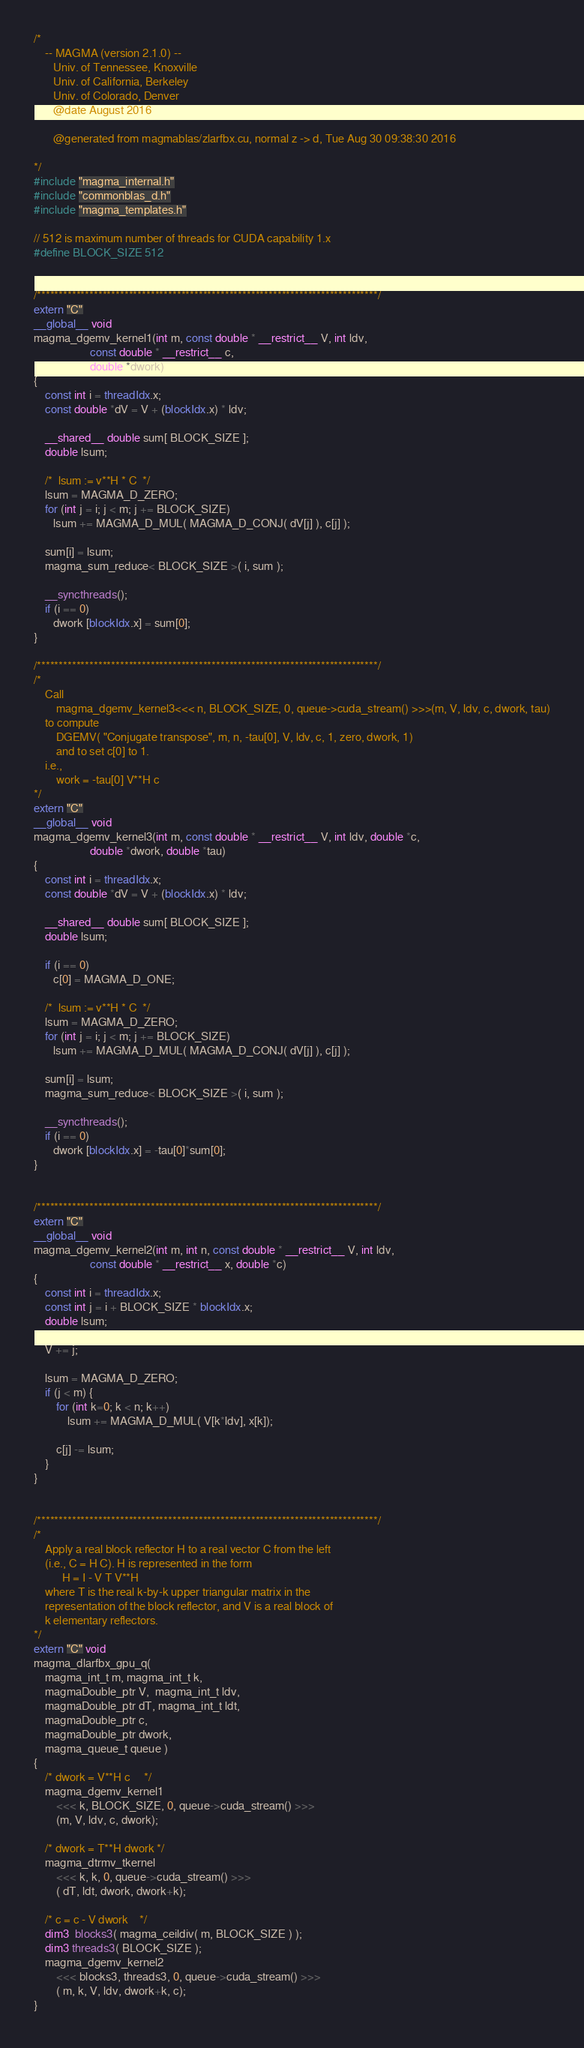Convert code to text. <code><loc_0><loc_0><loc_500><loc_500><_Cuda_>/*
    -- MAGMA (version 2.1.0) --
       Univ. of Tennessee, Knoxville
       Univ. of California, Berkeley
       Univ. of Colorado, Denver
       @date August 2016

       @generated from magmablas/zlarfbx.cu, normal z -> d, Tue Aug 30 09:38:30 2016

*/
#include "magma_internal.h"
#include "commonblas_d.h"
#include "magma_templates.h"

// 512 is maximum number of threads for CUDA capability 1.x
#define BLOCK_SIZE 512


/******************************************************************************/
extern "C"
__global__ void 
magma_dgemv_kernel1(int m, const double * __restrict__ V, int ldv, 
                    const double * __restrict__ c, 
                    double *dwork)
{
    const int i = threadIdx.x;
    const double *dV = V + (blockIdx.x) * ldv;

    __shared__ double sum[ BLOCK_SIZE ];
    double lsum;

    /*  lsum := v**H * C  */
    lsum = MAGMA_D_ZERO;
    for (int j = i; j < m; j += BLOCK_SIZE)
       lsum += MAGMA_D_MUL( MAGMA_D_CONJ( dV[j] ), c[j] );
    
    sum[i] = lsum;
    magma_sum_reduce< BLOCK_SIZE >( i, sum );

    __syncthreads();
    if (i == 0)
       dwork [blockIdx.x] = sum[0];
}

/******************************************************************************/
/*
    Call 
        magma_dgemv_kernel3<<< n, BLOCK_SIZE, 0, queue->cuda_stream() >>>(m, V, ldv, c, dwork, tau)
    to compute
        DGEMV( "Conjugate transpose", m, n, -tau[0], V, ldv, c, 1, zero, dwork, 1)
        and to set c[0] to 1.
    i.e., 
        work = -tau[0] V**H c
*/
extern "C"
__global__ void
magma_dgemv_kernel3(int m, const double * __restrict__ V, int ldv, double *c,
                    double *dwork, double *tau)
{
    const int i = threadIdx.x;
    const double *dV = V + (blockIdx.x) * ldv;

    __shared__ double sum[ BLOCK_SIZE ];
    double lsum;

    if (i == 0)
       c[0] = MAGMA_D_ONE;           

    /*  lsum := v**H * C  */
    lsum = MAGMA_D_ZERO;
    for (int j = i; j < m; j += BLOCK_SIZE)
       lsum += MAGMA_D_MUL( MAGMA_D_CONJ( dV[j] ), c[j] );

    sum[i] = lsum;
    magma_sum_reduce< BLOCK_SIZE >( i, sum );

    __syncthreads();
    if (i == 0)
       dwork [blockIdx.x] = -tau[0]*sum[0];
}


/******************************************************************************/
extern "C"
__global__ void
magma_dgemv_kernel2(int m, int n, const double * __restrict__ V, int ldv, 
                    const double * __restrict__ x, double *c)
{
    const int i = threadIdx.x;
    const int j = i + BLOCK_SIZE * blockIdx.x;
    double lsum;

    V += j;

    lsum = MAGMA_D_ZERO;
    if (j < m) {
        for (int k=0; k < n; k++)
            lsum += MAGMA_D_MUL( V[k*ldv], x[k]);
        
        c[j] -= lsum;
    }
}


/******************************************************************************/
/*
    Apply a real block reflector H to a real vector C from the left
    (i.e., C = H C). H is represented in the form
          H = I - V T V**H
    where T is the real k-by-k upper triangular matrix in the 
    representation of the block reflector, and V is a real block of
    k elementary reflectors. 
*/
extern "C" void
magma_dlarfbx_gpu_q(
    magma_int_t m, magma_int_t k,
    magmaDouble_ptr V,  magma_int_t ldv,
    magmaDouble_ptr dT, magma_int_t ldt,
    magmaDouble_ptr c,
    magmaDouble_ptr dwork,
    magma_queue_t queue )
{
    /* dwork = V**H c     */
    magma_dgemv_kernel1
        <<< k, BLOCK_SIZE, 0, queue->cuda_stream() >>>
        (m, V, ldv, c, dwork); 

    /* dwork = T**H dwork */
    magma_dtrmv_tkernel
        <<< k, k, 0, queue->cuda_stream() >>>
        ( dT, ldt, dwork, dwork+k);
 
    /* c = c - V dwork    */
    dim3  blocks3( magma_ceildiv( m, BLOCK_SIZE ) );
    dim3 threads3( BLOCK_SIZE );     
    magma_dgemv_kernel2
        <<< blocks3, threads3, 0, queue->cuda_stream() >>>
        ( m, k, V, ldv, dwork+k, c);
}
</code> 